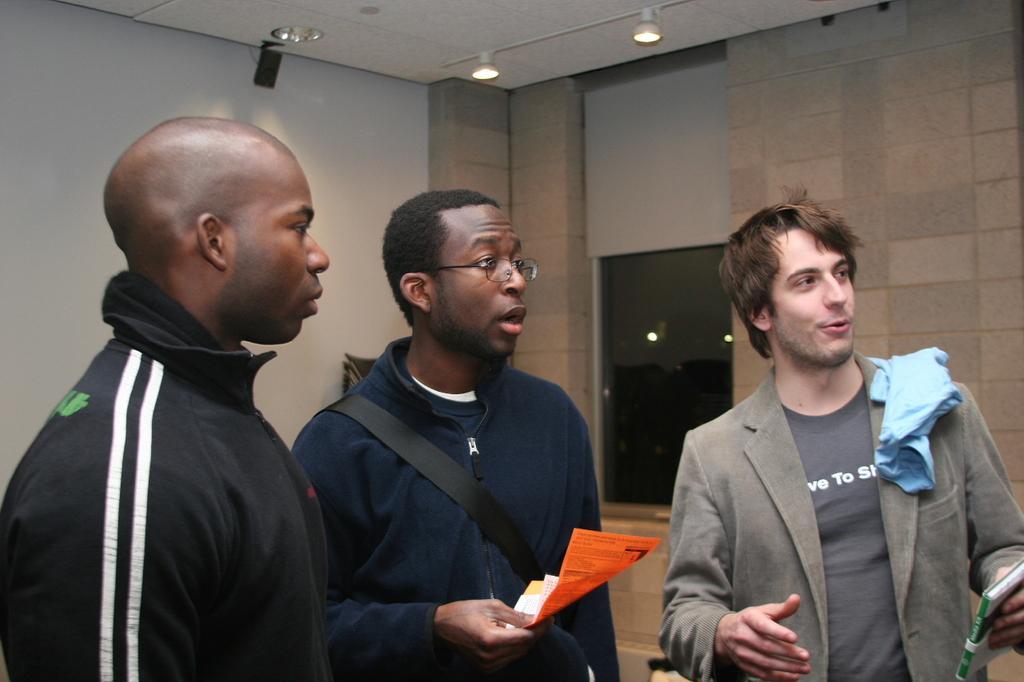How would you summarize this image in a sentence or two? In this image I can see 3 men standing in a room. The person standing in the center is holding papers. The person standing on the right is holding a book. There is a white board at the back and there is a window at the back. 